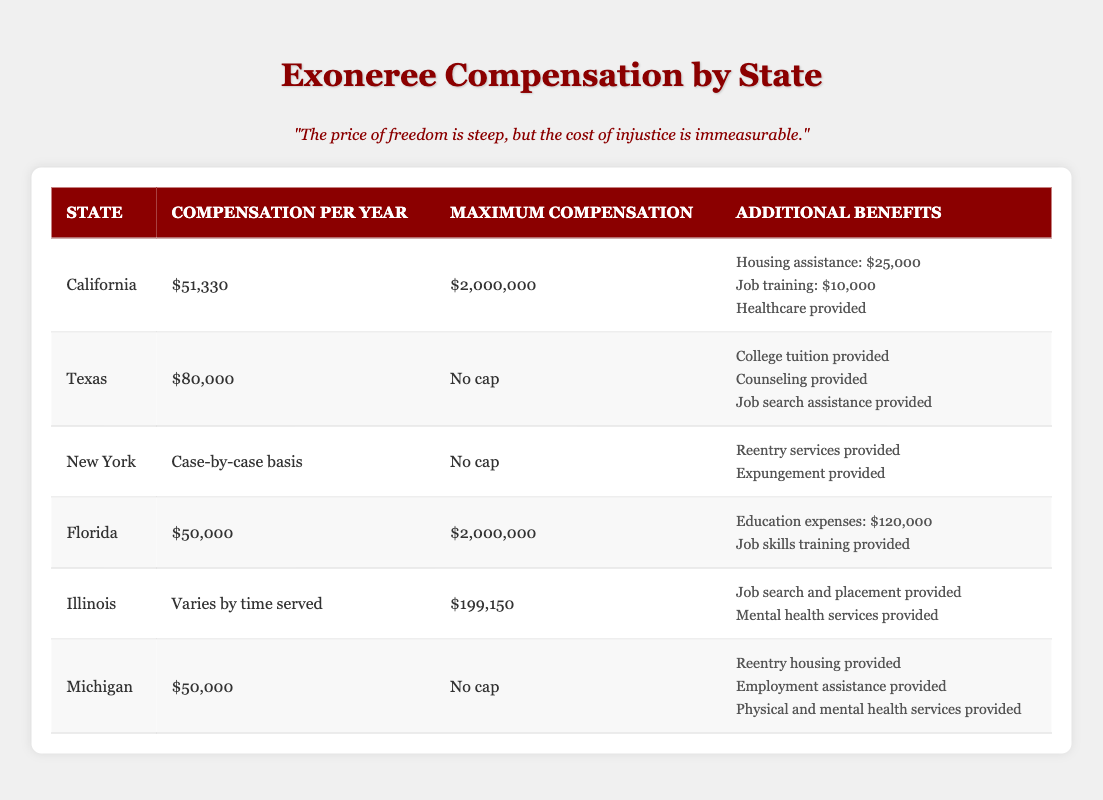What is the compensation per year for exonerees in Texas? According to the table, the compensation per year for exonerees in Texas is listed as $80,000.
Answer: $80,000 Which state has the highest maximum compensation listed? Both California and Florida have a maximum compensation of $2,000,000, which is the highest amount listed in the table.
Answer: California and Florida What additional benefits does Michigan provide for exonerees? Michigan offers additional benefits such as reentry housing, employment assistance, and physical and mental health services, as indicated in the table.
Answer: Reentry housing, employment assistance, physical and mental health services Is healthcare provided as an additional benefit in California? Yes, healthcare is provided as an additional benefit in California, as stated in the table.
Answer: Yes How does the compensation per year for exonerees in Florida compare to that in California? Florida offers compensation per year of $50,000, while California offers $51,330. To compare, $51,330 (California) - $50,000 (Florida) = $1,330. Therefore, California has higher compensation per year by $1,330.
Answer: $1,330 What is the total maximum compensation available to exonerees in both Florida and Illinois? The maximum compensation for Florida is $2,000,000, and for Illinois, it is $199,150. To find the total, add these two amounts: $2,000,000 + $199,150 = $2,199,150.
Answer: $2,199,150 Do any states in the table have a compensation per year that varies by time served? Yes, Illinois has a compensation per year that varies by time served, as stated clearly in the table.
Answer: Yes Which state provides no cap on maximum compensation? Both Texas and New York have "No cap" listed for maximum compensation, according to the table.
Answer: Texas and New York What is the maximum compensation listed for exonerees in Illinois? The maximum compensation listed for exonerees in Illinois is $199,150, as indicated in the table.
Answer: $199,150 